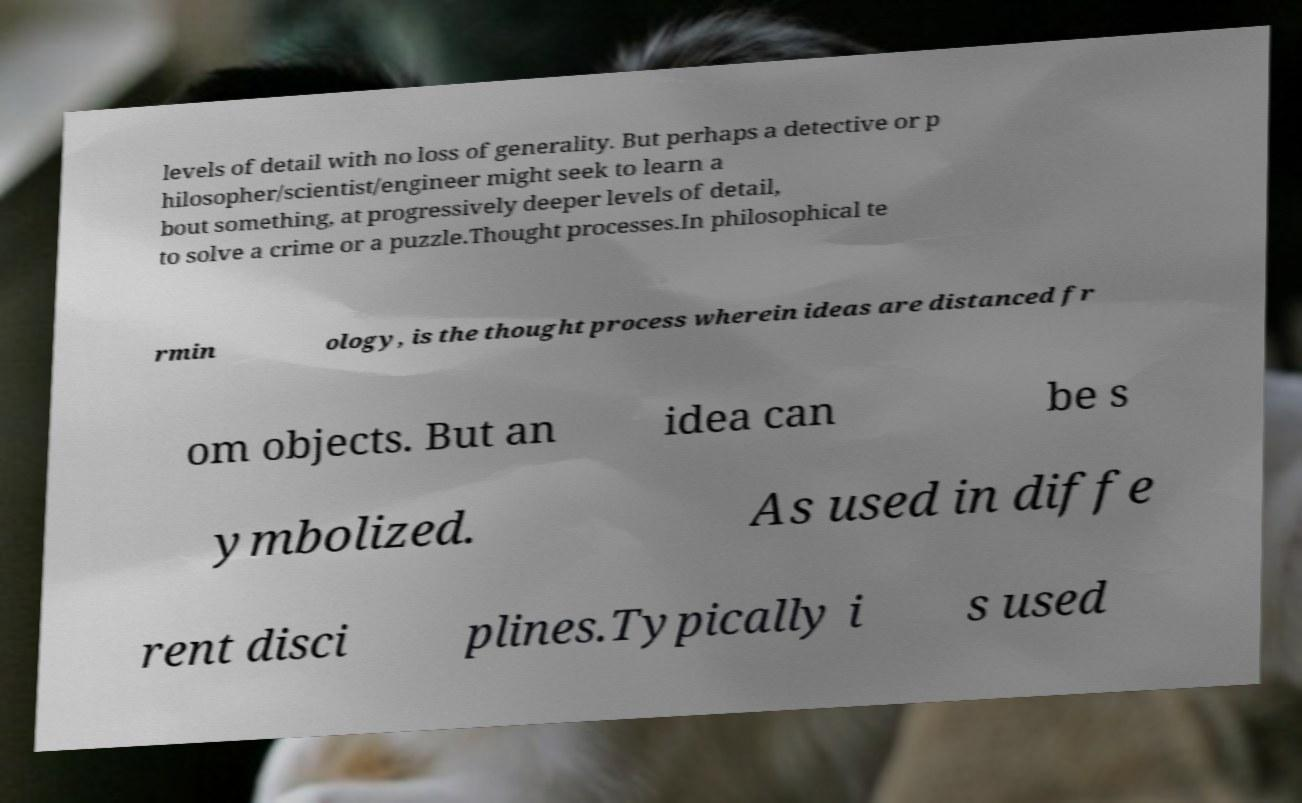For documentation purposes, I need the text within this image transcribed. Could you provide that? levels of detail with no loss of generality. But perhaps a detective or p hilosopher/scientist/engineer might seek to learn a bout something, at progressively deeper levels of detail, to solve a crime or a puzzle.Thought processes.In philosophical te rmin ology, is the thought process wherein ideas are distanced fr om objects. But an idea can be s ymbolized. As used in diffe rent disci plines.Typically i s used 